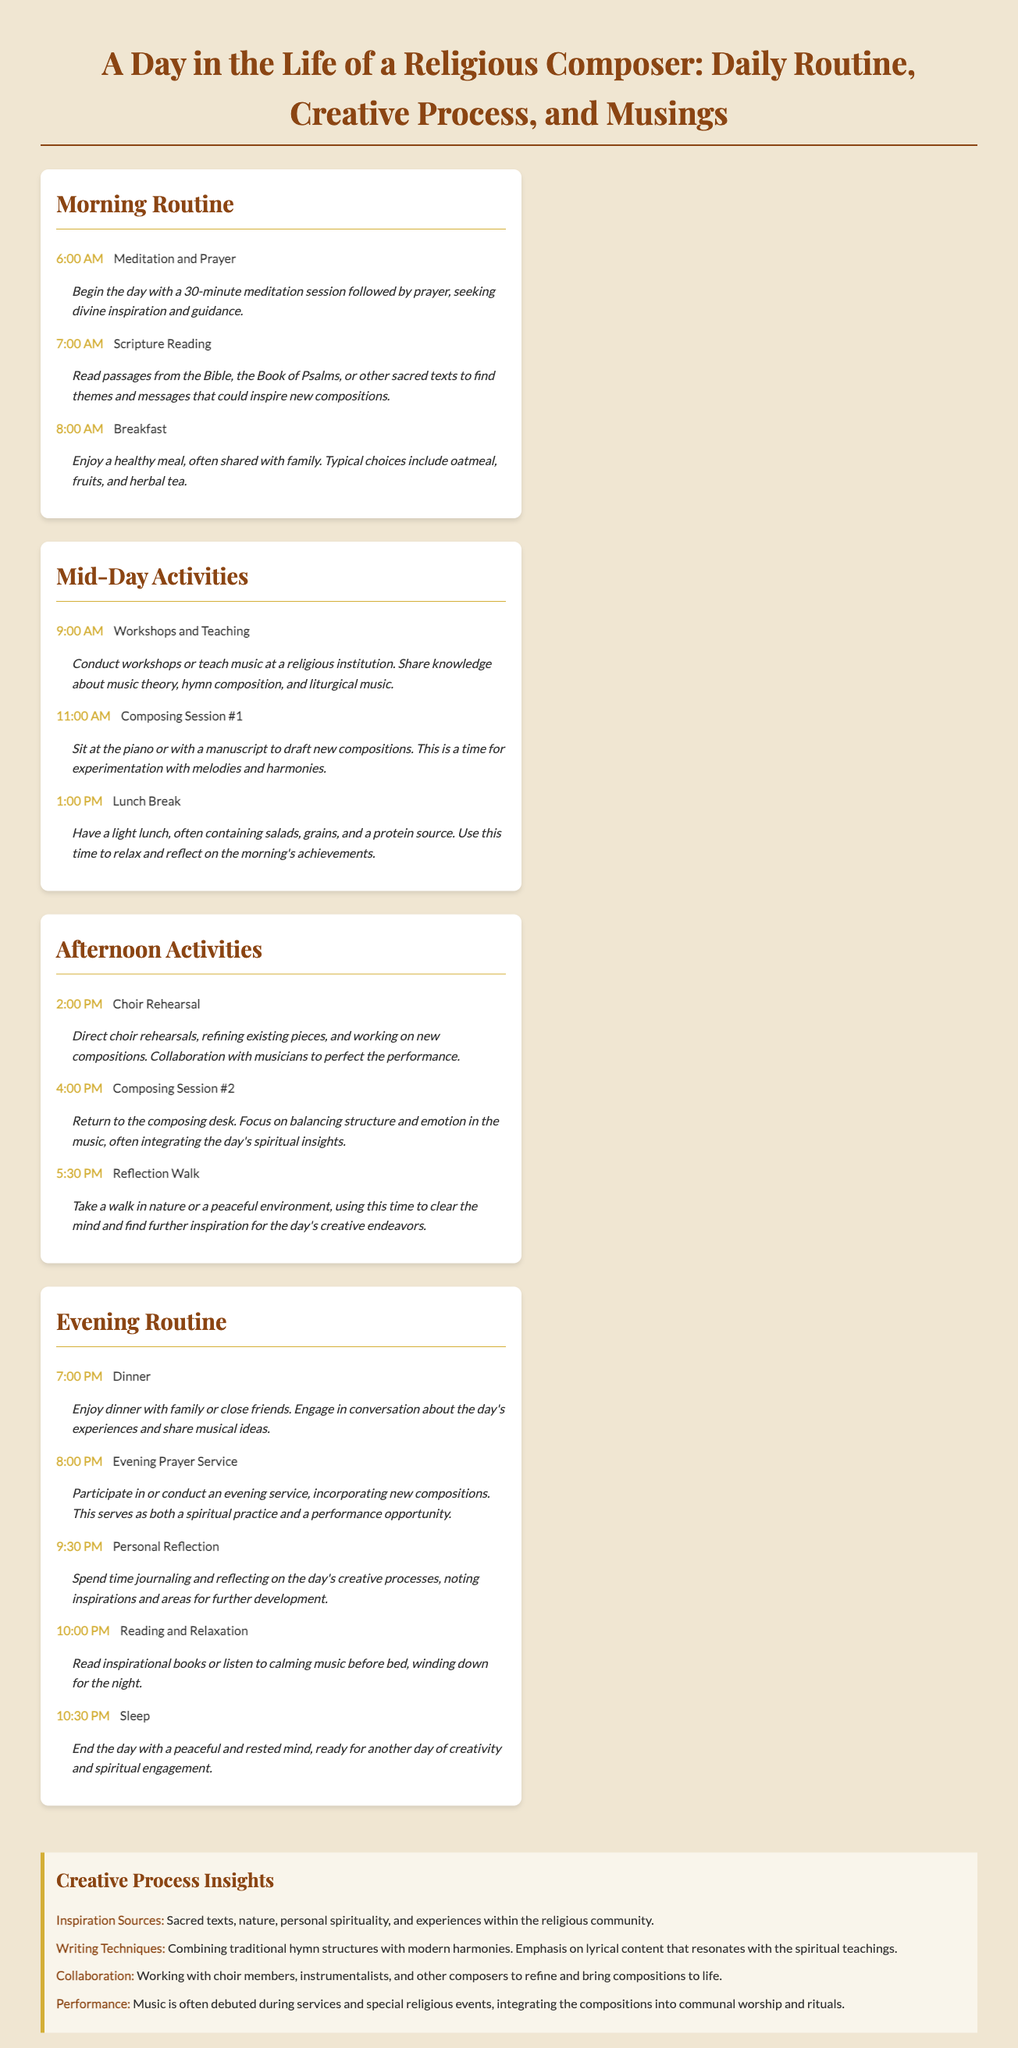What time does the composer wake up? The waking time is mentioned in the morning routine section, specifically for meditation and prayer activities.
Answer: 6:00 AM What activity follows scripture reading? The order of activities provides a clear sequence that identifies what comes next after scripture reading at 7:00 AM.
Answer: Breakfast How long is the first composing session? The document states a specific time block for the first composing session in the mid-day activities section.
Answer: 2 hours What is a key inspiration source for the composer? Several sources of inspiration are mentioned in the creative process insights, highlighting what motivates the composer's work.
Answer: Sacred texts What do the composers typically have for breakfast? The document describes the typical meal, providing insight into the composer’s dietary habits during breakfast.
Answer: Oatmeal, fruits, and herbal tea How many composing sessions are scheduled in a day? The document lists the composing sessions under the mid-day and afternoon activities sections, indicating the total count.
Answer: 2 sessions What time does the evening prayer service occur? The specific time for the evening prayer service is detailed in the evening routine section.
Answer: 8:00 PM What type of music does the composer focus on? The insights specify the type of music that combines different elements, emphasizing what the composer aims to create.
Answer: Hymn composition What activities happen immediately after lunch? The sequence of activities around lunchtime in the mid-day section helps identify what follows immediately afterwards.
Answer: Choir Rehearsal 